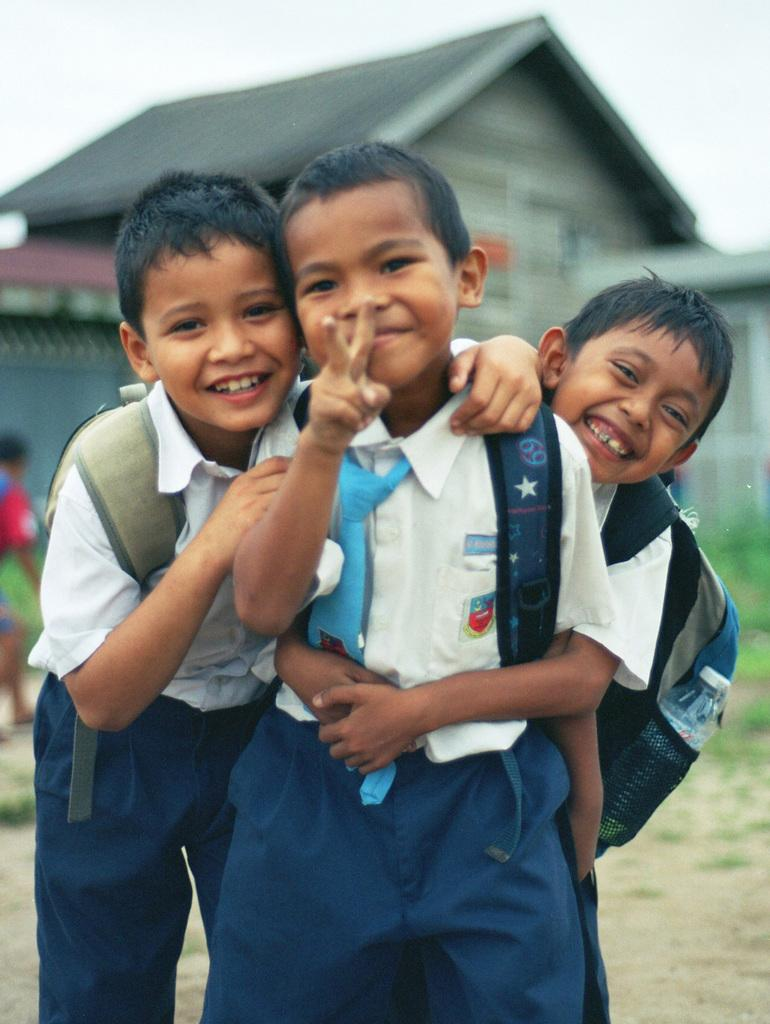How many boys are in the image? There are three boys standing and smiling in the center of the image. What is the boys' demeanor in the image? The boys are smiling in the image. What can be seen in the background of the image? There is a building and the sky visible in the background of the image. Where is the lady located in the image? The lady is on the left side of the image. What type of crate is being used to perform a trick by the boys in the image? There is no crate or trick being performed by the boys in the image; they are simply standing and smiling. 